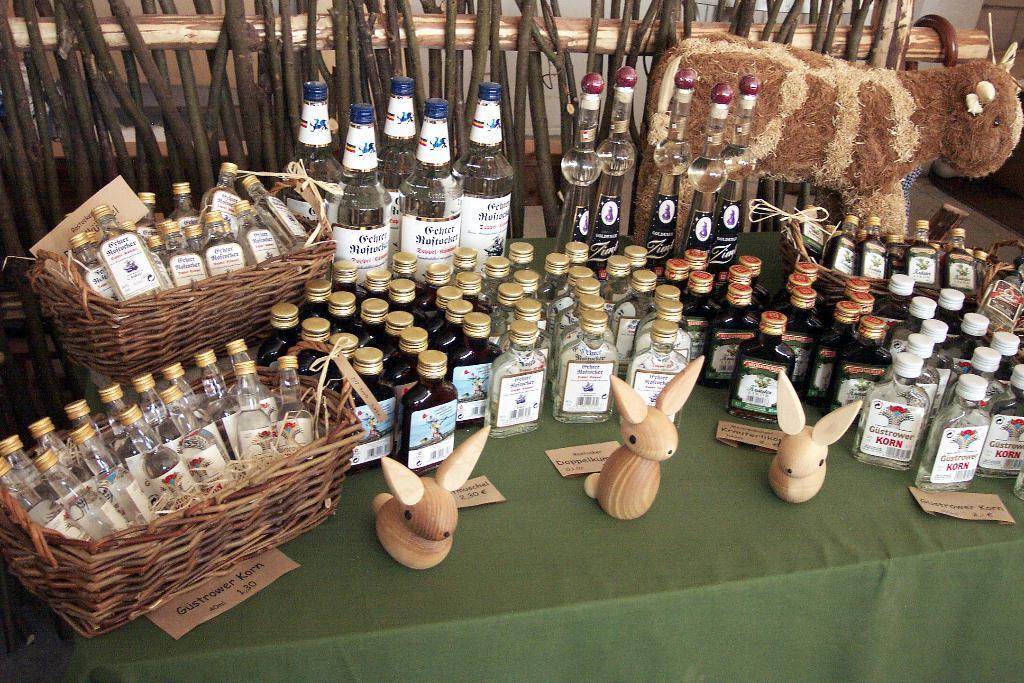How would you summarize this image in a sentence or two? In this image we can see a group of bottles, toys made of wood, some papers with text on them, a group of bottles in the baskets and a toy woolly sheep which are placed on the table. On the backside we can see a group of sticks and a walking stick to a wooden pole. 